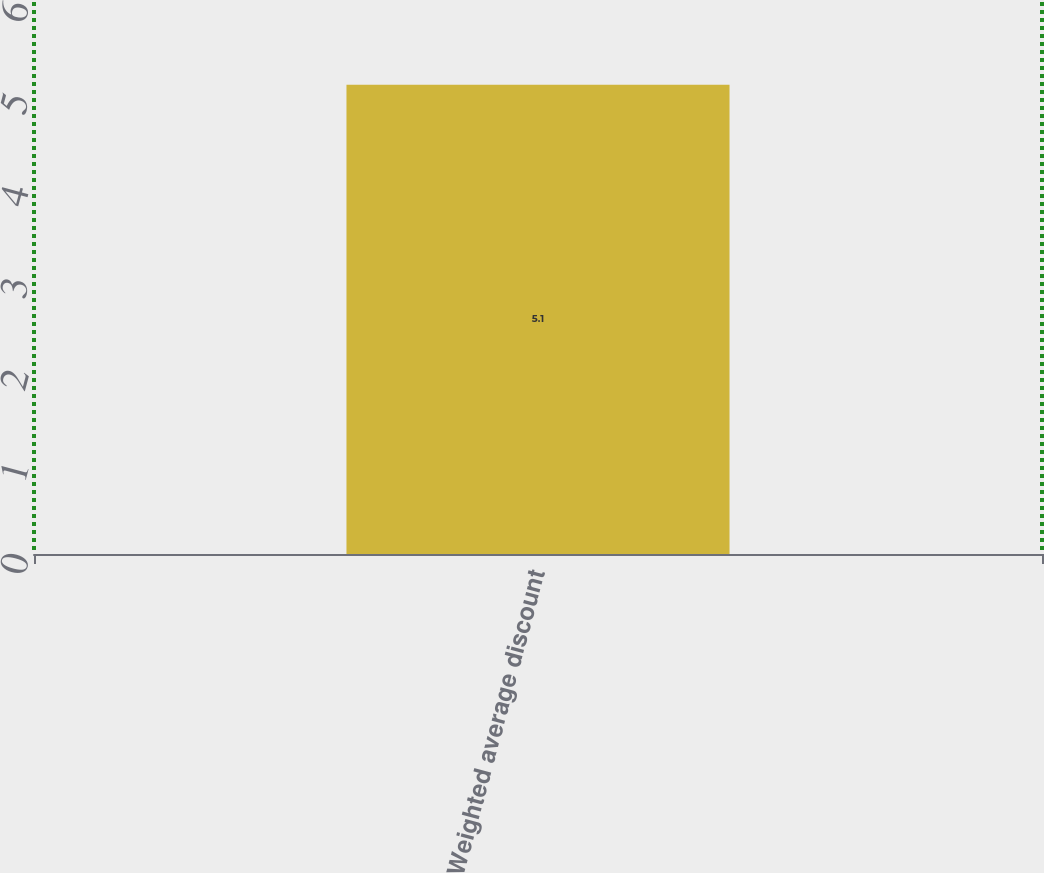Convert chart. <chart><loc_0><loc_0><loc_500><loc_500><bar_chart><fcel>Weighted average discount<nl><fcel>5.1<nl></chart> 